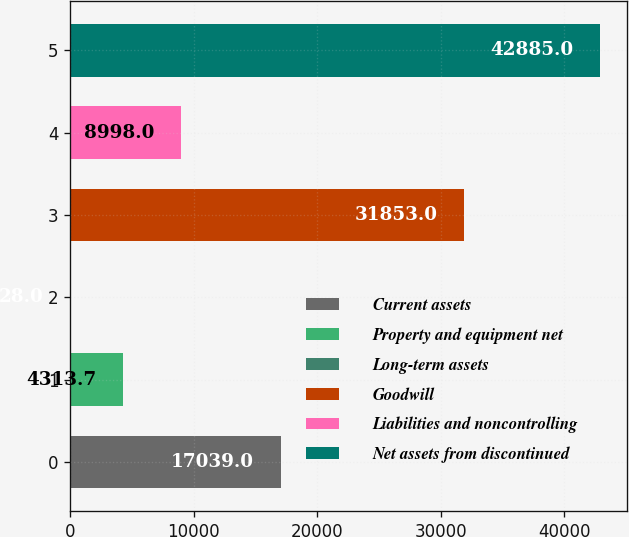Convert chart to OTSL. <chart><loc_0><loc_0><loc_500><loc_500><bar_chart><fcel>Current assets<fcel>Property and equipment net<fcel>Long-term assets<fcel>Goodwill<fcel>Liabilities and noncontrolling<fcel>Net assets from discontinued<nl><fcel>17039<fcel>4313.7<fcel>28<fcel>31853<fcel>8998<fcel>42885<nl></chart> 